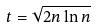Convert formula to latex. <formula><loc_0><loc_0><loc_500><loc_500>t = \sqrt { 2 n \ln n }</formula> 